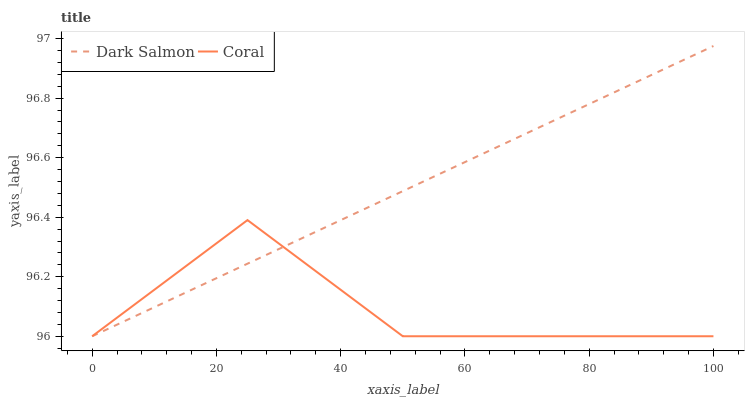Does Coral have the minimum area under the curve?
Answer yes or no. Yes. Does Dark Salmon have the maximum area under the curve?
Answer yes or no. Yes. Does Dark Salmon have the minimum area under the curve?
Answer yes or no. No. Is Dark Salmon the smoothest?
Answer yes or no. Yes. Is Coral the roughest?
Answer yes or no. Yes. Is Dark Salmon the roughest?
Answer yes or no. No. Does Coral have the lowest value?
Answer yes or no. Yes. Does Dark Salmon have the highest value?
Answer yes or no. Yes. Does Dark Salmon intersect Coral?
Answer yes or no. Yes. Is Dark Salmon less than Coral?
Answer yes or no. No. Is Dark Salmon greater than Coral?
Answer yes or no. No. 